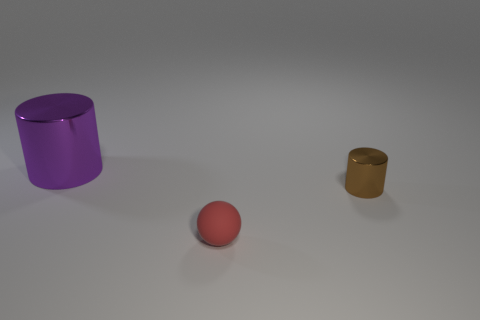Is there any other thing of the same color as the small cylinder?
Ensure brevity in your answer.  No. There is a purple thing that is the same shape as the brown thing; what material is it?
Provide a succinct answer. Metal. Do the large purple shiny thing and the tiny red object have the same shape?
Keep it short and to the point. No. There is a purple thing that is the same material as the tiny brown thing; what is its shape?
Give a very brief answer. Cylinder. How many green things are either small rubber balls or large cylinders?
Your answer should be compact. 0. Is there a shiny cylinder that is to the right of the small thing that is in front of the metal cylinder in front of the purple cylinder?
Offer a terse response. Yes. Is the number of large purple shiny cylinders less than the number of small blue rubber cylinders?
Offer a very short reply. No. Is the shape of the metallic object that is to the right of the purple cylinder the same as  the purple object?
Keep it short and to the point. Yes. Is there a brown ball?
Offer a very short reply. No. What color is the rubber thing in front of the object that is behind the object that is to the right of the tiny red ball?
Provide a succinct answer. Red. 